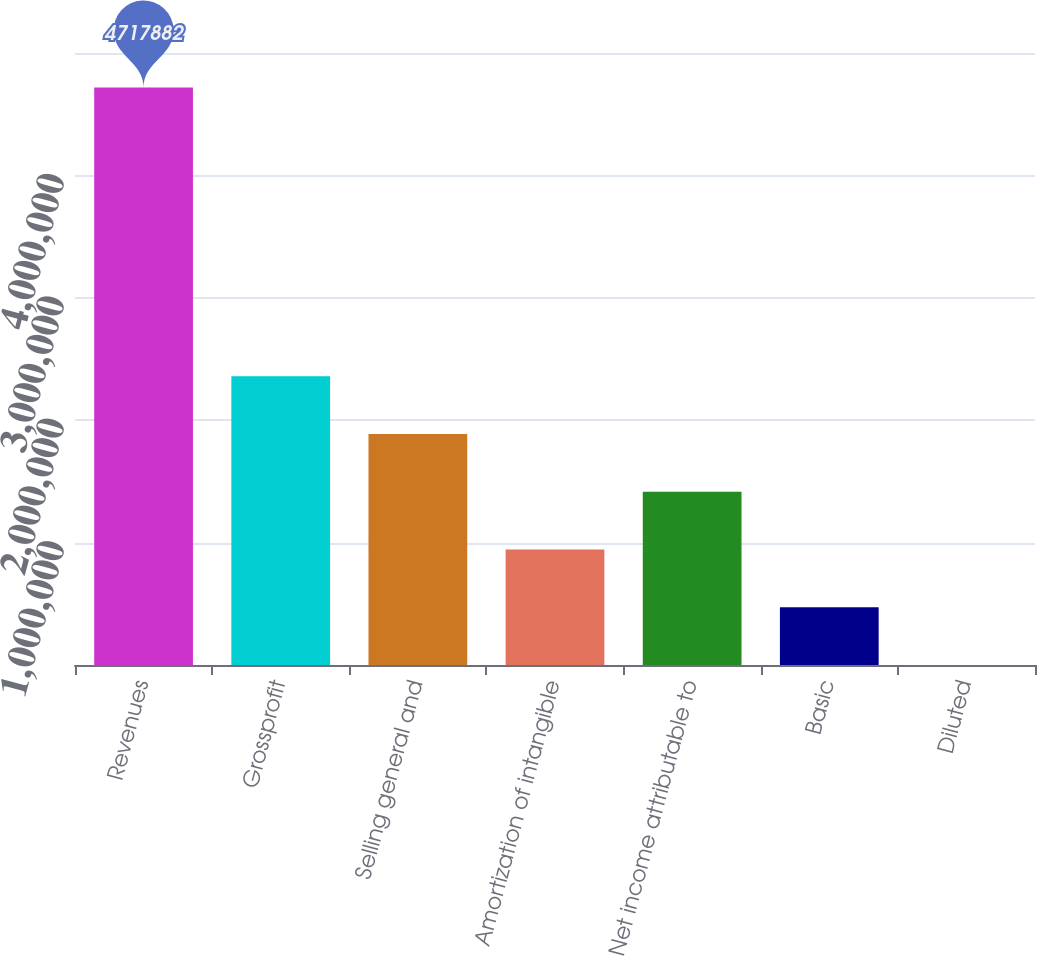Convert chart to OTSL. <chart><loc_0><loc_0><loc_500><loc_500><bar_chart><fcel>Revenues<fcel>Grossprofit<fcel>Selling general and<fcel>Amortization of intangible<fcel>Net income attributable to<fcel>Basic<fcel>Diluted<nl><fcel>4.71788e+06<fcel>2.35894e+06<fcel>1.88715e+06<fcel>943578<fcel>1.41537e+06<fcel>471789<fcel>1.41<nl></chart> 